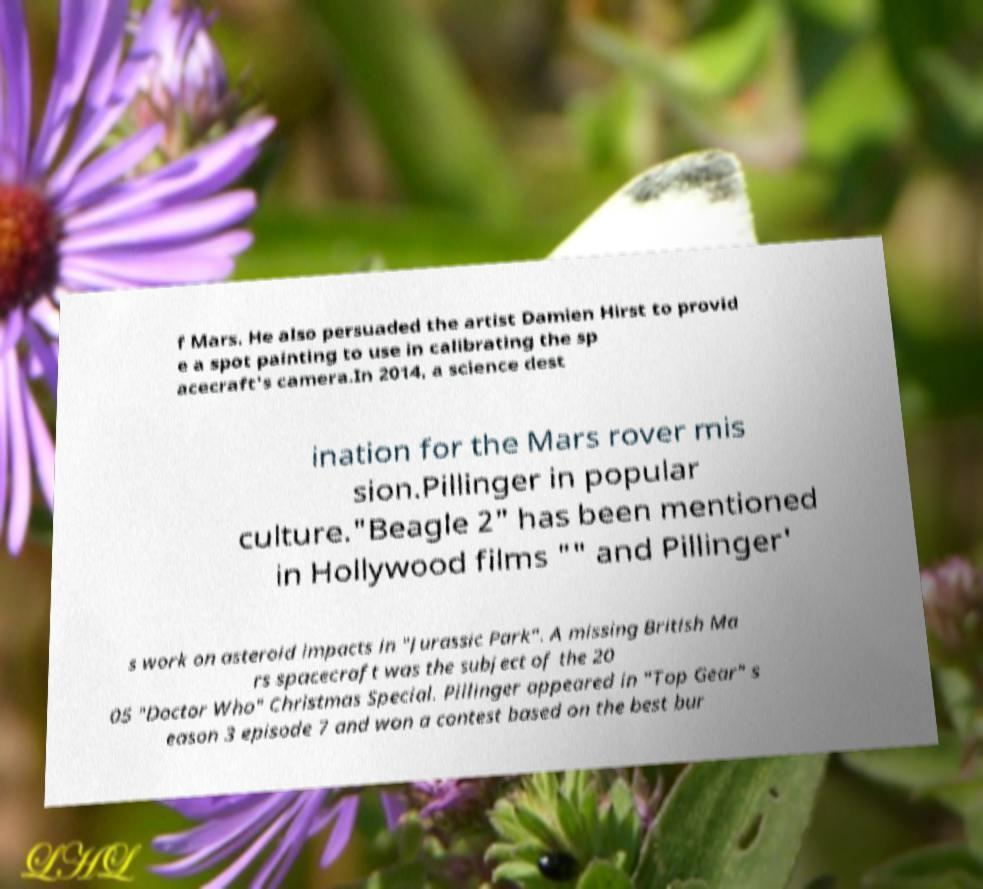For documentation purposes, I need the text within this image transcribed. Could you provide that? f Mars. He also persuaded the artist Damien Hirst to provid e a spot painting to use in calibrating the sp acecraft's camera.In 2014, a science dest ination for the Mars rover mis sion.Pillinger in popular culture."Beagle 2" has been mentioned in Hollywood films "" and Pillinger' s work on asteroid impacts in "Jurassic Park". A missing British Ma rs spacecraft was the subject of the 20 05 "Doctor Who" Christmas Special. Pillinger appeared in "Top Gear" s eason 3 episode 7 and won a contest based on the best bur 